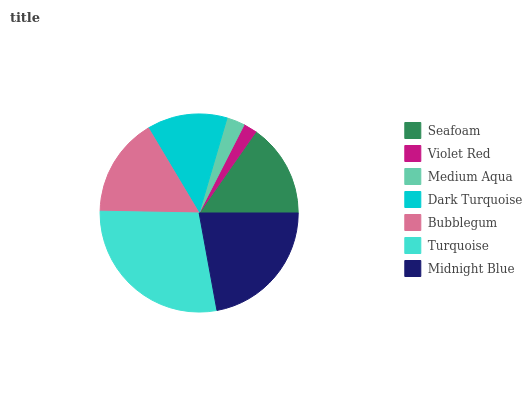Is Violet Red the minimum?
Answer yes or no. Yes. Is Turquoise the maximum?
Answer yes or no. Yes. Is Medium Aqua the minimum?
Answer yes or no. No. Is Medium Aqua the maximum?
Answer yes or no. No. Is Medium Aqua greater than Violet Red?
Answer yes or no. Yes. Is Violet Red less than Medium Aqua?
Answer yes or no. Yes. Is Violet Red greater than Medium Aqua?
Answer yes or no. No. Is Medium Aqua less than Violet Red?
Answer yes or no. No. Is Seafoam the high median?
Answer yes or no. Yes. Is Seafoam the low median?
Answer yes or no. Yes. Is Midnight Blue the high median?
Answer yes or no. No. Is Medium Aqua the low median?
Answer yes or no. No. 